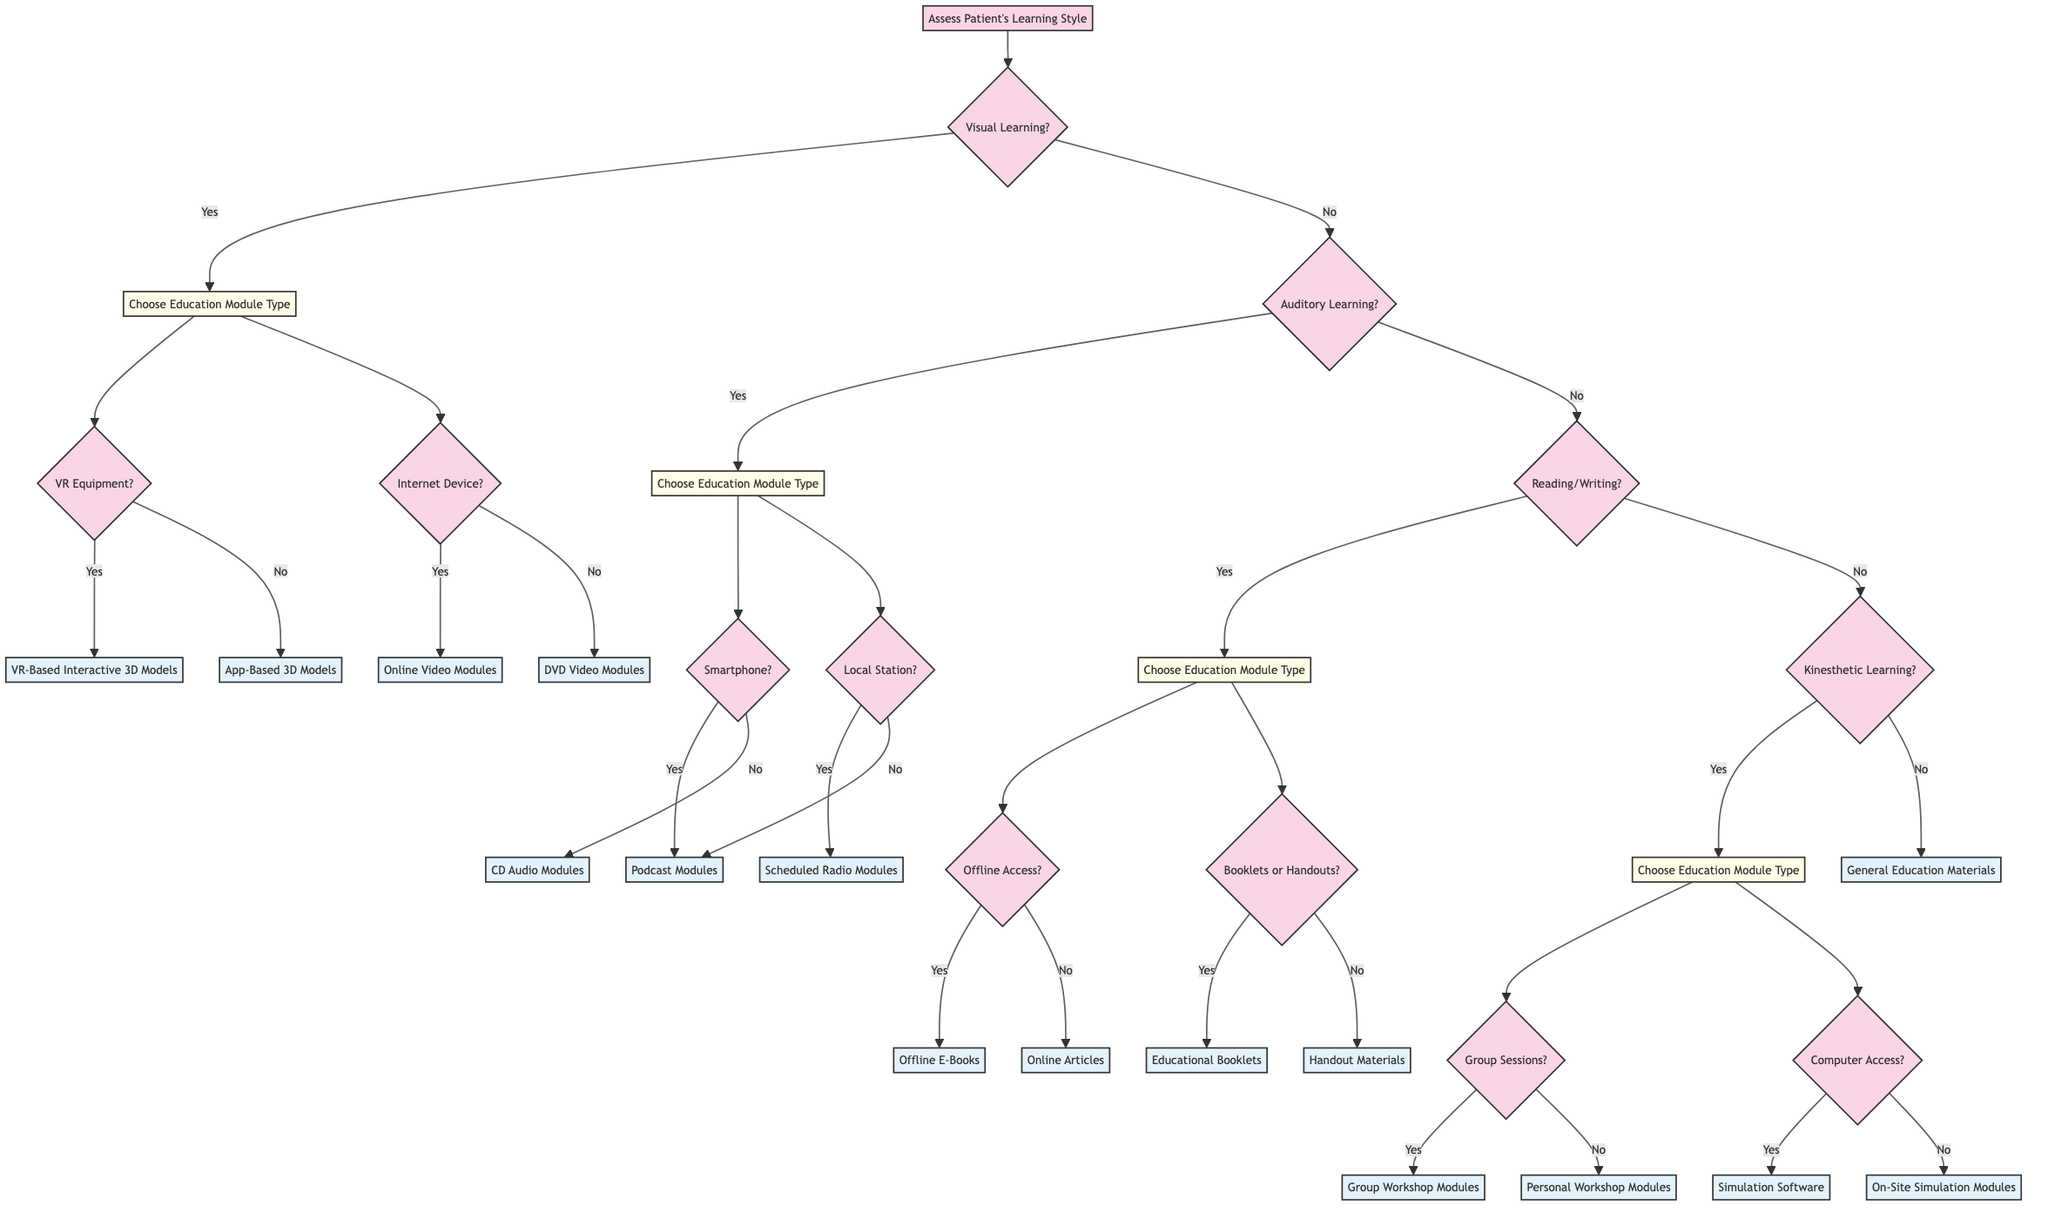What is the first action in the decision tree? The first action is to assess the patient's learning style, which is represented at the starting node of the diagram. This node does not require any prior conditions to be met and initiates the decision-making process.
Answer: Assess Patient's Learning Style How many module types are available for visual learners? There are two module types available for visual learners: Interactive 3D Models and Video Tutorials. This information can be found under the visual learning question branch.
Answer: 2 What happens if the patient prefers auditory learning and has a smartphone? If the patient prefers auditory learning and has a smartphone, they will be offered downloadable podcasts, which are classified under the audio podcasts branch. This path starts with the auditory learning question leading to the smartphone condition.
Answer: Offer downloadable podcasts What is the outcome if a patient prefers kinesthetic learning but does not have computer access? If a patient prefers kinesthetic learning but does not have computer access, they will be offered on-site simulation sessions. This decision is reached by following the kinesthetic learning question, then directly going to the computer access question which leads to the appropriate module.
Answer: Offer on-site simulation sessions How many total education modules are available in the decision tree? There are a total of 11 distinct education modules listed throughout the decision tree that result from various branches depending on patient preferences. After counting each unique module node, it totals up.
Answer: 11 What does offering printed materials depend on? Offering printed materials depends on whether the patient prefers booklets or handouts. This decision requires assessing the patient's basic preferences about the format of printed educational resources.
Answer: Booklets or Handouts Which module is reached by a patient who prefers reading/writing and needs offline access? A patient who prefers reading/writing methods and needs offline access will be directed to the Offline E-Books module. This conclusion can be reached by following the appropriate branches in the decision tree for reading/writing preferences and offline access condition.
Answer: Offline E-Books What is the last resort offered if none of the learning styles fit? If none of the learning styles fit, the last resort is to recommend general educational resources, which is explicitly stated at the end of the decision branches for learning preferences.
Answer: General Education Materials 